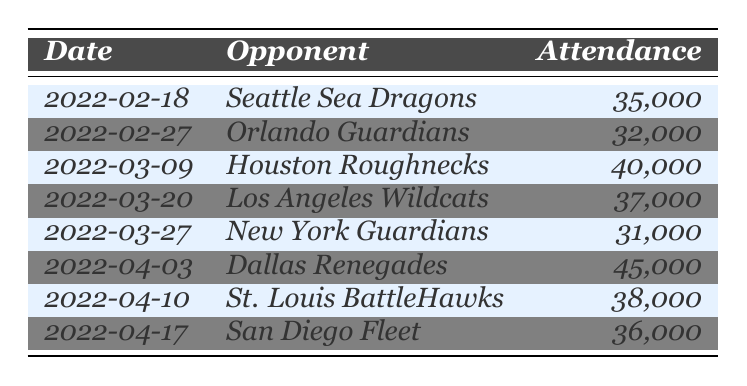What was the highest attendance at a San Antonio Brahmas home game in 2022? The highest attendance can be found by examining the attendance column. The highest number listed is 45,000 for the game against the Dallas Renegades on April 3, 2022.
Answer: 45,000 Which opponent did the San Antonio Brahmas have the lowest attendance against? To find the lowest attendance, compare all the attendance figures. The lowest figure is 31,000, which occurred during the game against the New York Guardians on March 27, 2022.
Answer: New York Guardians What was the average attendance for the games played on March 9, March 20, and April 10? First, sum the attendances for those specific dates: 40,000 + 37,000 + 38,000 = 115,000. Then, divide by the number of games (3): 115,000 / 3 = 38,333.33. Hence, the average attendance is approximately 38,333.
Answer: Approximately 38,333 Did the San Antonio Brahmas have more than 35,000 attendees at all home games? Checking the attendance figures against 35,000 reveals that out of the 8 games played, one game (February 27) had fewer than 35,000 attendees (32,000). Therefore, not all games had more than 35,000 attendees.
Answer: No What were the total attendance figures for the games played in February? The attendance figures for February are 35,000 (Seattle Sea Dragons) and 32,000 (Orlando Guardians). Adding these figures gives 35,000 + 32,000 = 67,000, so the total attendance for February games is 67,000.
Answer: 67,000 How many games had an attendance of 36,000 or more? By examining the attendance figures, count the number of games with 36,000 or more: (35,000, 32,000, 40,000, 37,000, 31,000, 45,000, 38,000, 36,000) yields 5 games: against Houston Roughnecks, Los Angeles Wildcats, Dallas Renegades, St. Louis BattleHawks, and San Diego Fleet.
Answer: 5 Which opponent had an attendance figure close to 38,000? Looking through the attendance figures, the games against the St. Louis BattleHawks (38,000) and Los Angeles Wildcats (37,000) are closest to 38,000.
Answer: St. Louis BattleHawks and Los Angeles Wildcats What percentage of the games had attendance figures below 35,000? There are 8 games total. The game against the Orlando Guardians had an attendance of 32,000, which is below 35,000. That makes 1 out of 8 games; to find the percentage, calculate (1/8) * 100 = 12.5%.
Answer: 12.5% Was there a trend of increasing attendance figures as the season progressed? To determine a trend, one must observe the attendance figures chronologically: 35,000, 32,000, 40,000, 37,000, 31,000, 45,000, 38,000, and 36,000. The values fluctuate rather than consistently increase, showing no clear upward trend.
Answer: No clear trend 